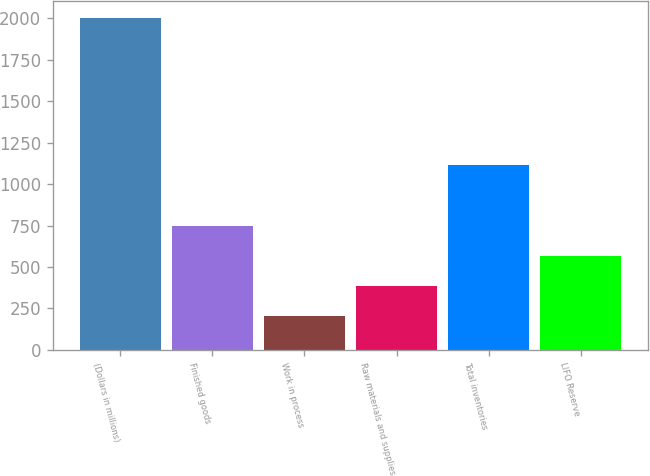<chart> <loc_0><loc_0><loc_500><loc_500><bar_chart><fcel>(Dollars in millions)<fcel>Finished goods<fcel>Work in process<fcel>Raw materials and supplies<fcel>Total inventories<fcel>LIFO Reserve<nl><fcel>2005<fcel>746.4<fcel>207<fcel>386.8<fcel>1118<fcel>566.6<nl></chart> 